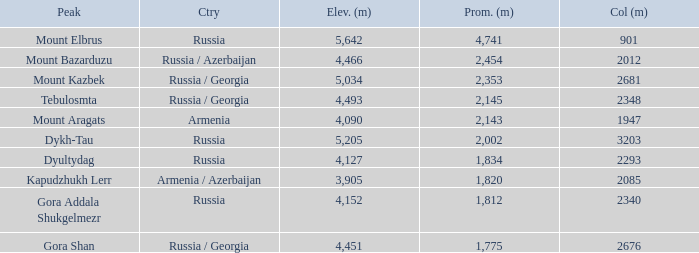What is the Elevation (m) of the Peak with a Prominence (m) larger than 2,143 and Col (m) of 2012? 4466.0. 